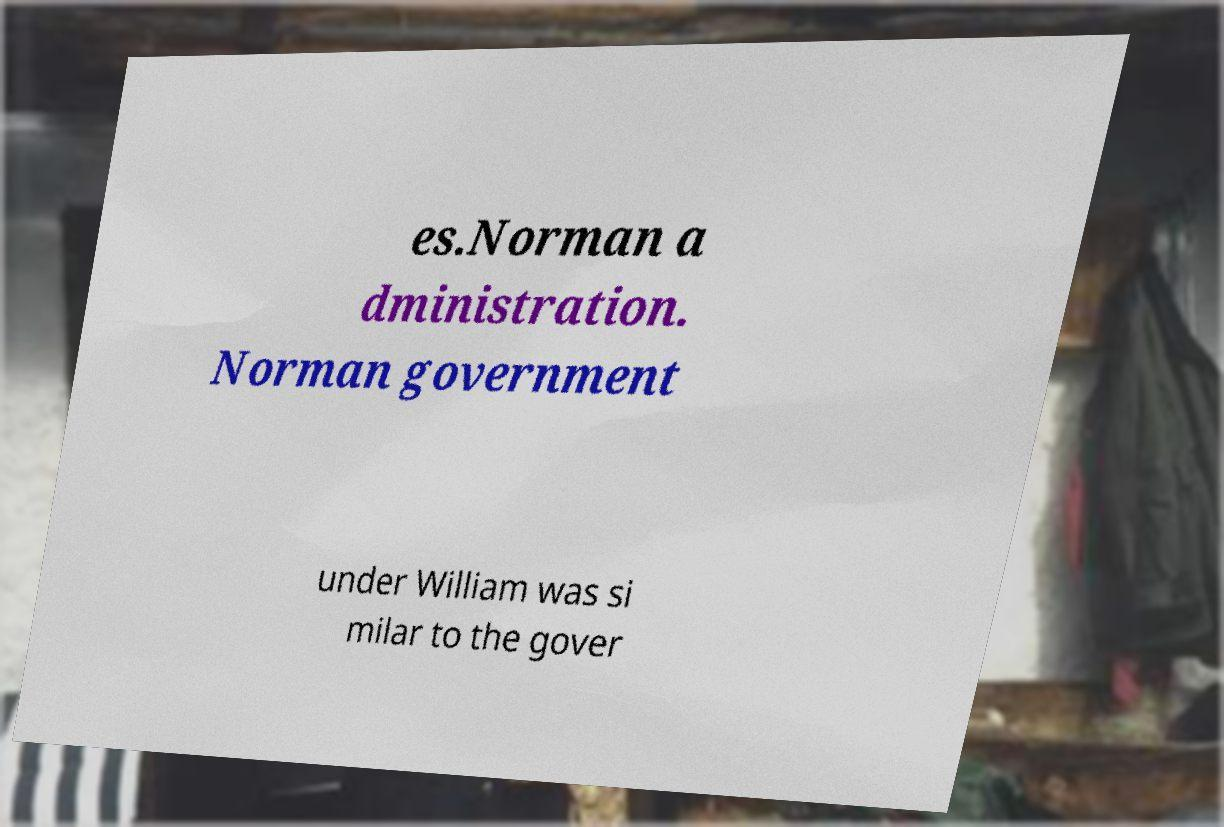Please identify and transcribe the text found in this image. es.Norman a dministration. Norman government under William was si milar to the gover 